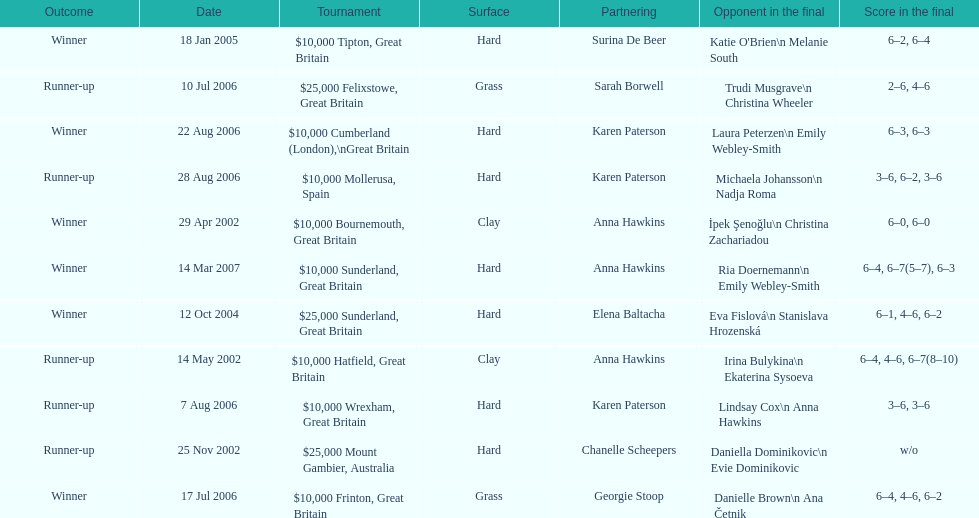How many tournaments has jane o'donoghue competed in? 11. 